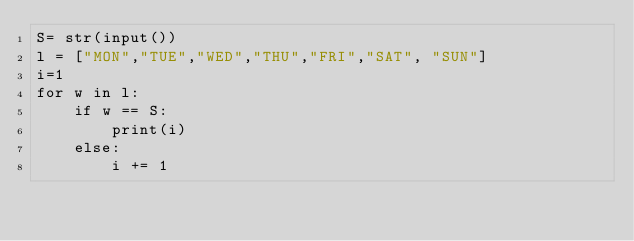Convert code to text. <code><loc_0><loc_0><loc_500><loc_500><_Python_>S= str(input())
l = ["MON","TUE","WED","THU","FRI","SAT", "SUN"]
i=1
for w in l:
    if w == S:
        print(i)
    else:
        i += 1
</code> 